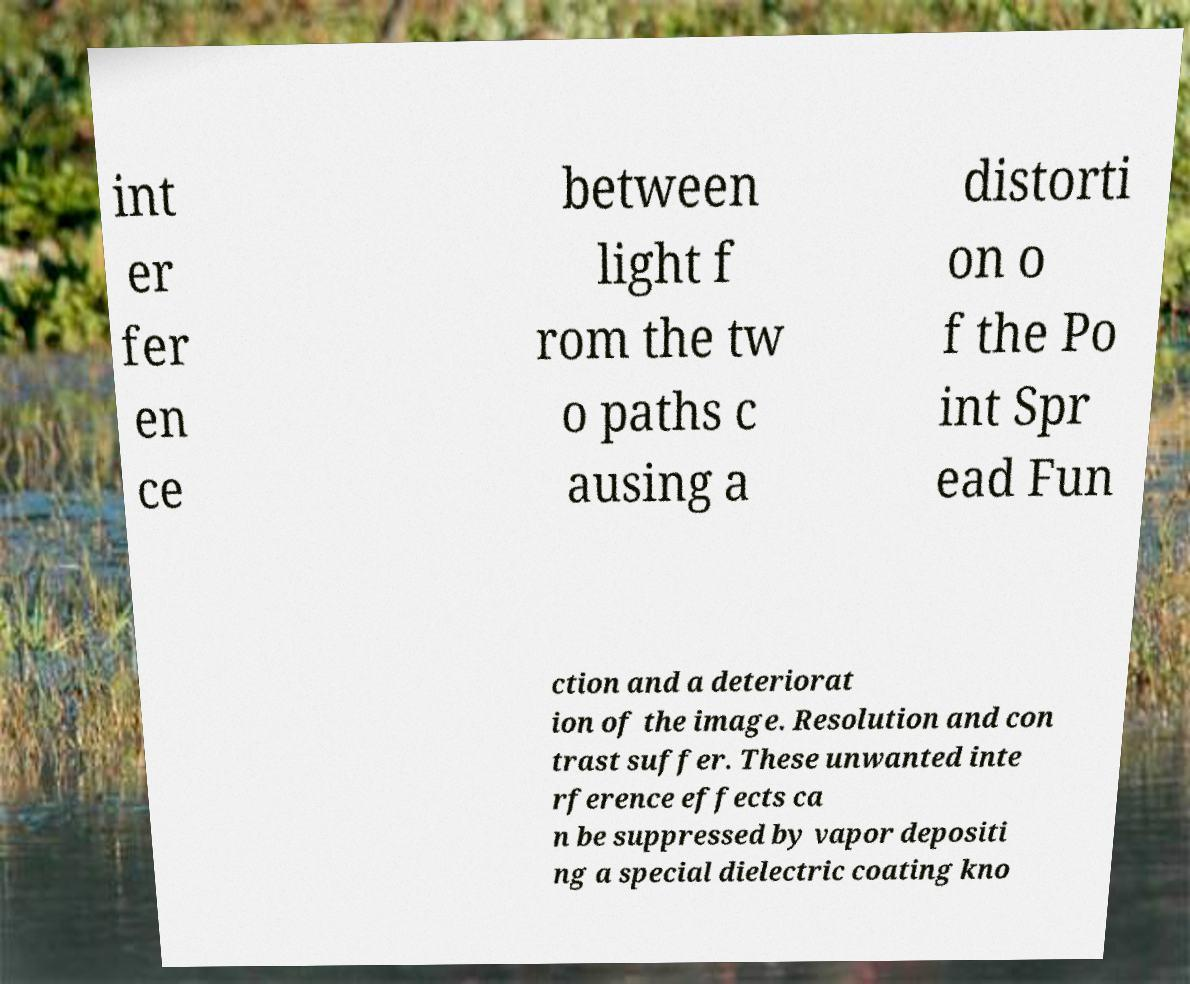I need the written content from this picture converted into text. Can you do that? int er fer en ce between light f rom the tw o paths c ausing a distorti on o f the Po int Spr ead Fun ction and a deteriorat ion of the image. Resolution and con trast suffer. These unwanted inte rference effects ca n be suppressed by vapor depositi ng a special dielectric coating kno 